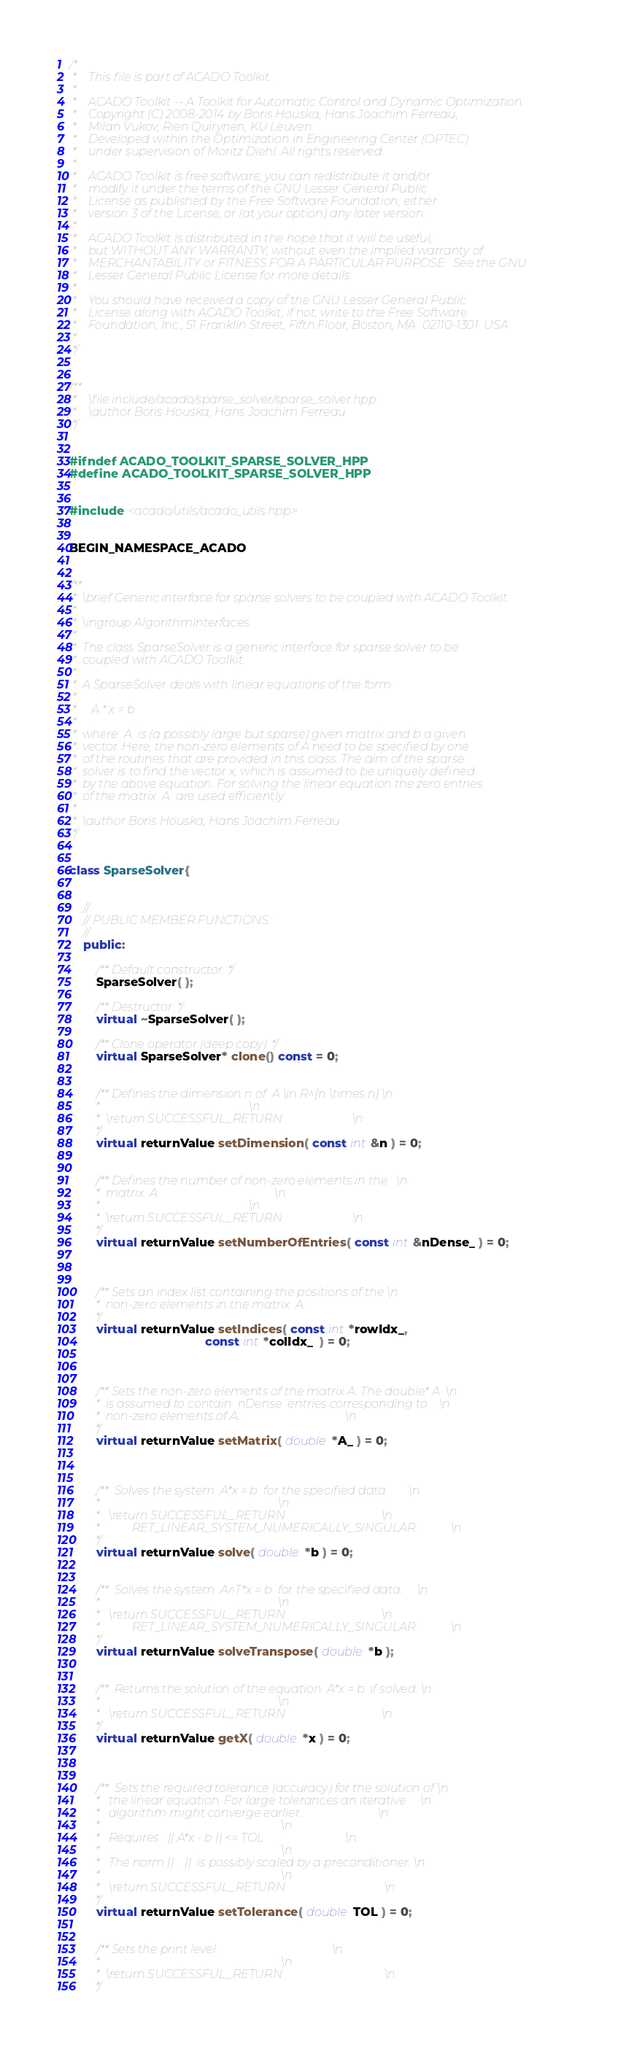Convert code to text. <code><loc_0><loc_0><loc_500><loc_500><_C++_>/*
 *    This file is part of ACADO Toolkit.
 *
 *    ACADO Toolkit -- A Toolkit for Automatic Control and Dynamic Optimization.
 *    Copyright (C) 2008-2014 by Boris Houska, Hans Joachim Ferreau,
 *    Milan Vukov, Rien Quirynen, KU Leuven.
 *    Developed within the Optimization in Engineering Center (OPTEC)
 *    under supervision of Moritz Diehl. All rights reserved.
 *
 *    ACADO Toolkit is free software; you can redistribute it and/or
 *    modify it under the terms of the GNU Lesser General Public
 *    License as published by the Free Software Foundation; either
 *    version 3 of the License, or (at your option) any later version.
 *
 *    ACADO Toolkit is distributed in the hope that it will be useful,
 *    but WITHOUT ANY WARRANTY; without even the implied warranty of
 *    MERCHANTABILITY or FITNESS FOR A PARTICULAR PURPOSE.  See the GNU
 *    Lesser General Public License for more details.
 *
 *    You should have received a copy of the GNU Lesser General Public
 *    License along with ACADO Toolkit; if not, write to the Free Software
 *    Foundation, Inc., 51 Franklin Street, Fifth Floor, Boston, MA  02110-1301  USA
 *
 */


/**
 *    \file include/acado/sparse_solver/sparse_solver.hpp
 *    \author Boris Houska, Hans Joachim Ferreau
 */


#ifndef ACADO_TOOLKIT_SPARSE_SOLVER_HPP
#define ACADO_TOOLKIT_SPARSE_SOLVER_HPP


#include <acado/utils/acado_utils.hpp>


BEGIN_NAMESPACE_ACADO


/**
 *	\brief Generic interface for sparse solvers to be coupled with ACADO Toolkit.
 *
 *	\ingroup AlgorithmInterfaces
 *
 *  The class SparseSolver is a generic interface for sparse solver to be
 *  coupled with ACADO Toolkit.
 *
 *  A SparseSolver deals with linear equations of the form
 *
 *     A * x = b
 *
 *  where  A  is (a possibly large but sparse) given matrix and b a given
 *  vector. Here, the non-zero elements of A need to be specified by one
 *  of the routines that are provided in this class. The aim of the sparse
 *  solver is to find the vector x, which is assumed to be uniquely defined
 *  by the above equation. For solving the linear equation the zero entries
 *  of the matrix  A  are used efficiently.
 *
 *  \author Boris Houska, Hans Joachim Ferreau
 */


class SparseSolver{


    //
    // PUBLIC MEMBER FUNCTIONS:
    //
    public:

        /** Default constructor. */
        SparseSolver( );

        /** Destructor. */
        virtual ~SparseSolver( );

        /** Clone operator (deep copy). */
        virtual SparseSolver* clone() const = 0;


        /** Defines the dimension n of  A \in R^{n \times n} \n
         *                                                   \n
         *  \return SUCCESSFUL_RETURN                        \n
         */
        virtual returnValue setDimension( const int &n ) = 0;


        /** Defines the number of non-zero elements in the   \n
         *  matrix  A                                        \n
         *                                                   \n
         *  \return SUCCESSFUL_RETURN                        \n
         */
        virtual returnValue setNumberOfEntries( const int &nDense_ ) = 0;



        /** Sets an index list containing the positions of the \n
         *  non-zero elements in the matrix  A.
         */
        virtual returnValue setIndices( const int *rowIdx_,
                                        const int *colIdx_  ) = 0;



        /** Sets the non-zero elements of the matrix A. The double* A  \n
         *  is assumed to contain  nDense  entries corresponding to    \n
         *  non-zero elements of A.                                    \n
         */
        virtual returnValue setMatrix( double *A_ ) = 0;



        /**  Solves the system  A*x = b  for the specified data.       \n
         *                                                             \n
         *   \return SUCCESSFUL_RETURN                                 \n
         *           RET_LINEAR_SYSTEM_NUMERICALLY_SINGULAR            \n
         */
        virtual returnValue solve( double *b ) = 0;


        /**  Solves the system  A^T*x = b  for the specified data.     \n
         *                                                             \n
         *   \return SUCCESSFUL_RETURN                                 \n
         *           RET_LINEAR_SYSTEM_NUMERICALLY_SINGULAR            \n
         */
        virtual returnValue solveTranspose( double *b );


        /**  Returns the solution of the equation  A*x = b  if solved. \n
         *                                                             \n
         *   \return SUCCESSFUL_RETURN                                 \n
         */
        virtual returnValue getX( double *x ) = 0;



        /**  Sets the required tolerance (accuracy) for the solution of \n
         *   the linear equation. For large tolerances an iterative     \n
         *   algorithm might converge earlier.                          \n
         *                                                              \n
         *   Requires   || A*x - b || <= TOL                            \n
         *                                                              \n
         *   The norm || .  ||  is possibly scaled by a preconditioner. \n
         *                                                              \n
         *   \return SUCCESSFUL_RETURN                                  \n
         */
        virtual returnValue setTolerance( double TOL ) = 0;


        /** Sets the print level.                                       \n
         *                                                              \n
         *  \return SUCCESSFUL_RETURN                                   \n
         */</code> 